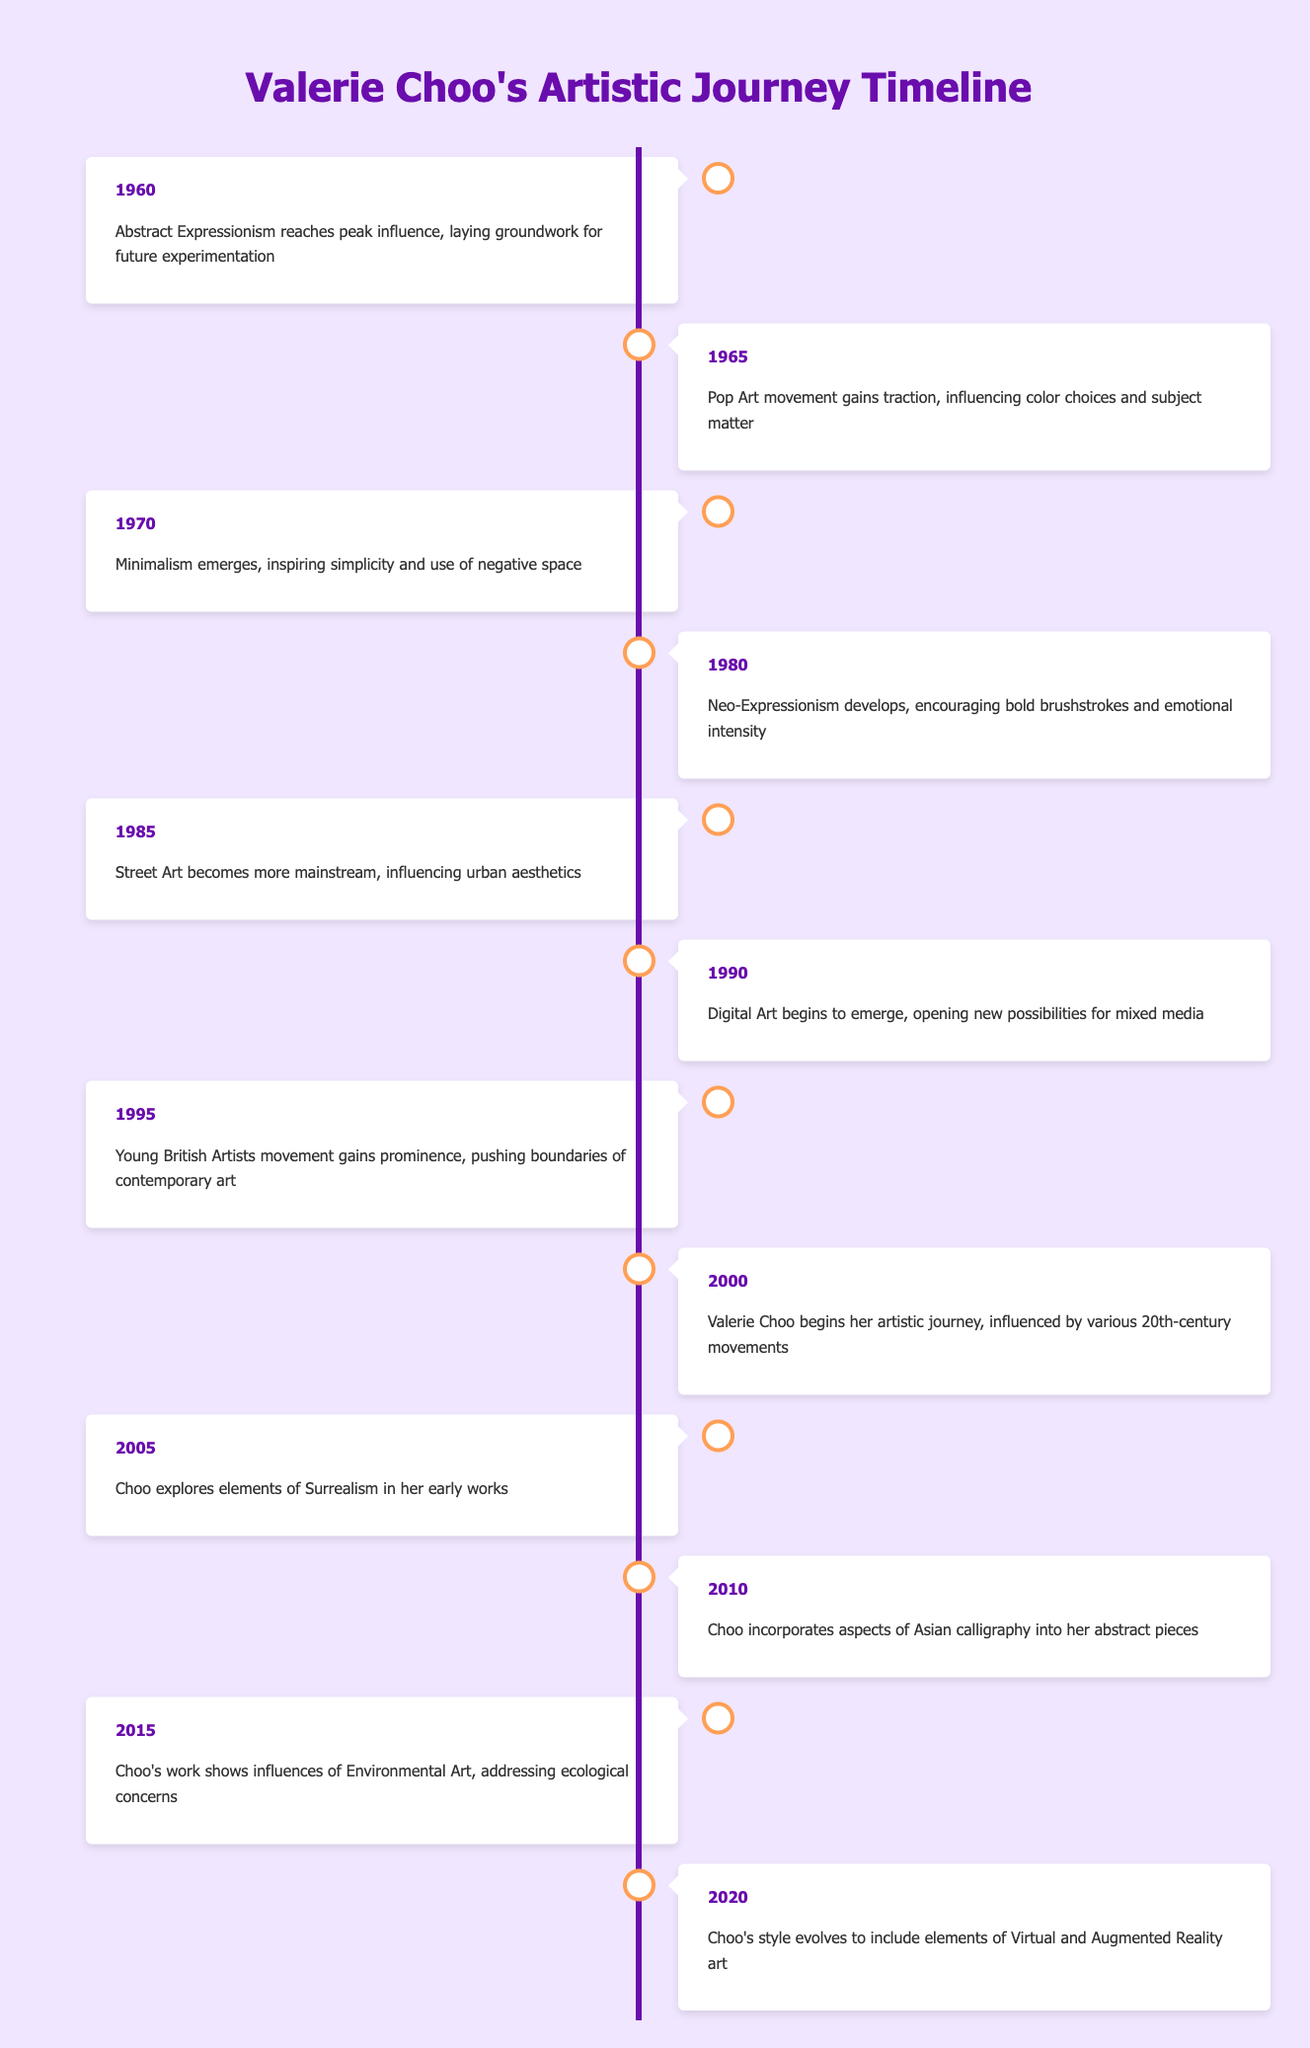What year did Valerie Choo begin her artistic journey? The table indicates that Valerie Choo began her artistic journey in the year 2000.
Answer: 2000 What is the influence of the Pop Art movement on Choo's work? The table notes that the Pop Art movement gained traction in 1965, influencing color choices and subject matter in art, which could have impacts on Valerie Choo's later works.
Answer: Color choices and subject matter Was Surrealism a part of Valerie Choo's exploration in her early works? According to the table, Choo explored elements of Surrealism in her early works starting from 2005.
Answer: Yes What art movement reached its peak influence in 1960? The table states that Abstract Expressionism reached peak influence in 1960.
Answer: Abstract Expressionism How many years are there between the emergence of Minimalism and Neo-Expressionism? According to the table, Minimalism emerged in 1970 and Neo-Expressionism developed in 1980, so the difference is 1980 - 1970 = 10 years.
Answer: 10 years What are the two movements that influenced the color and subject matter of art before Valerie Choo started working in 2000? The Pop Art movement in 1965 influenced color choices and subject matter, and prior to that, Abstract Expressionism was influential in 1960. Both movements laid groundwork for Choo’s style.
Answer: Abstract Expressionism and Pop Art Which year did Valerie Choo incorporate aspects of Asian calligraphy into her art? The timeline shows that Valerie Choo incorporated aspects of Asian calligraphy into her abstract pieces in 2010.
Answer: 2010 What is the significance of the Young British Artists movement in relation to contemporary art? The table indicates that the Young British Artists movement gained prominence in 1995, pushing the boundaries of contemporary art, which signifies its importance.
Answer: It pushed boundaries of contemporary art In what way did Choo's style evolve by the year 2020? By 2020, the table reveals that Choo's style evolved to include elements of Virtual and Augmented Reality art, indicating an adaptation to modern technology in her practice.
Answer: Included Virtual and Augmented Reality art 